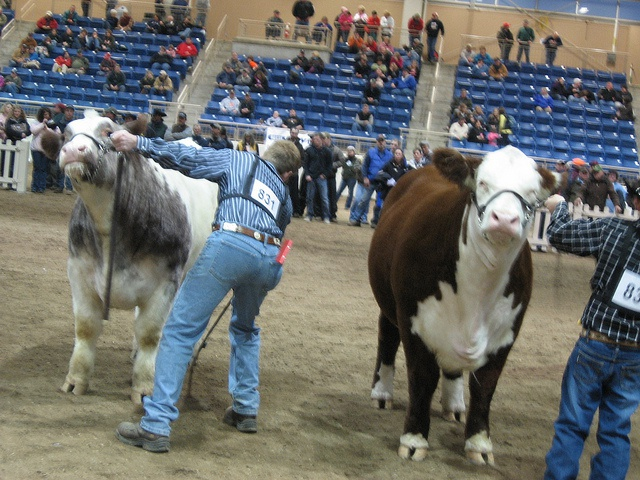Describe the objects in this image and their specific colors. I can see people in gray, black, navy, and darkgray tones, cow in gray, black, darkgray, and white tones, cow in gray, darkgray, black, and white tones, people in gray and darkgray tones, and people in gray, black, navy, and darkblue tones in this image. 